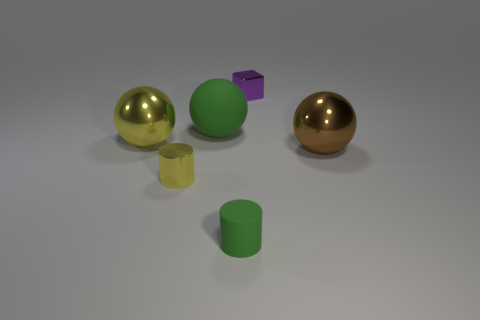How many big objects are to the right of the purple block and left of the tiny purple metallic object?
Your answer should be very brief. 0. What color is the small shiny cube?
Your response must be concise. Purple. Is there another green object that has the same material as the small green thing?
Your answer should be very brief. Yes. Is there a rubber object behind the green rubber object that is behind the tiny metal thing that is in front of the cube?
Give a very brief answer. No. There is a big yellow shiny sphere; are there any big metal objects behind it?
Provide a succinct answer. No. Is there a large rubber object that has the same color as the small rubber thing?
Your response must be concise. Yes. How many large objects are red shiny spheres or purple blocks?
Give a very brief answer. 0. Does the ball that is in front of the large yellow shiny ball have the same material as the big green thing?
Make the answer very short. No. What is the shape of the small metal object that is in front of the small object that is behind the big object right of the tiny purple block?
Give a very brief answer. Cylinder. How many blue objects are matte cylinders or small metallic cylinders?
Offer a very short reply. 0. 